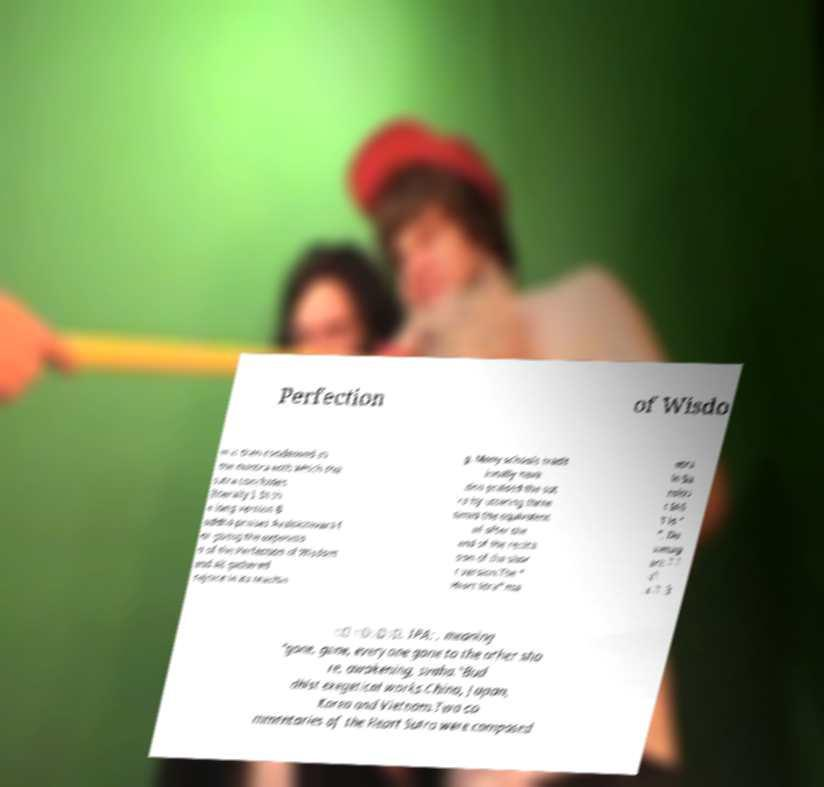Please read and relay the text visible in this image. What does it say? Perfection of Wisdo m is then condensed in the mantra with which the sutra concludes (literally ). In th e long version B uddha praises Avalokitevara f or giving the expositio n of the Perfection of Wisdom and all gathered rejoice in its teachin g. Many schools tradit ionally have also praised the sut ra by uttering three times the equivalent of after the end of the recita tion of the shor t version.The " Heart Stra" ma ntra in Sa nskri t IAS T is " ", De vanag ari: े े ाे ांे ो ि ्ाा, IPA: , meaning "gone, gone, everyone gone to the other sho re, awakening, svaha."Bud dhist exegetical works.China, Japan, Korea and Vietnam.Two co mmentaries of the Heart Sutra were composed 